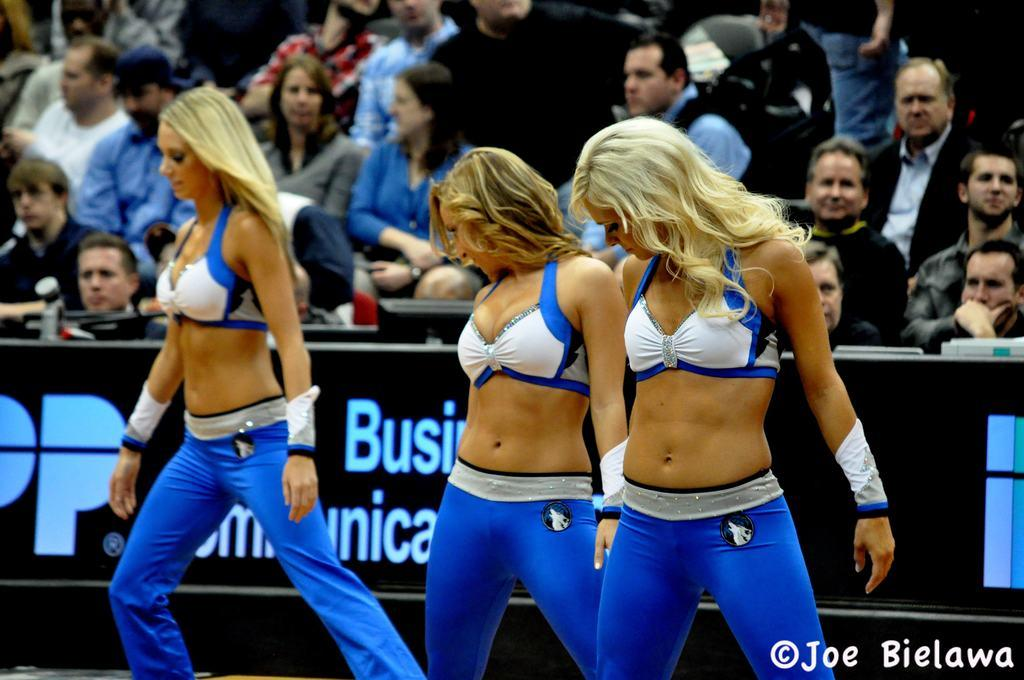<image>
Share a concise interpretation of the image provided. Three dancers perform in front of a Business Communications sign. 